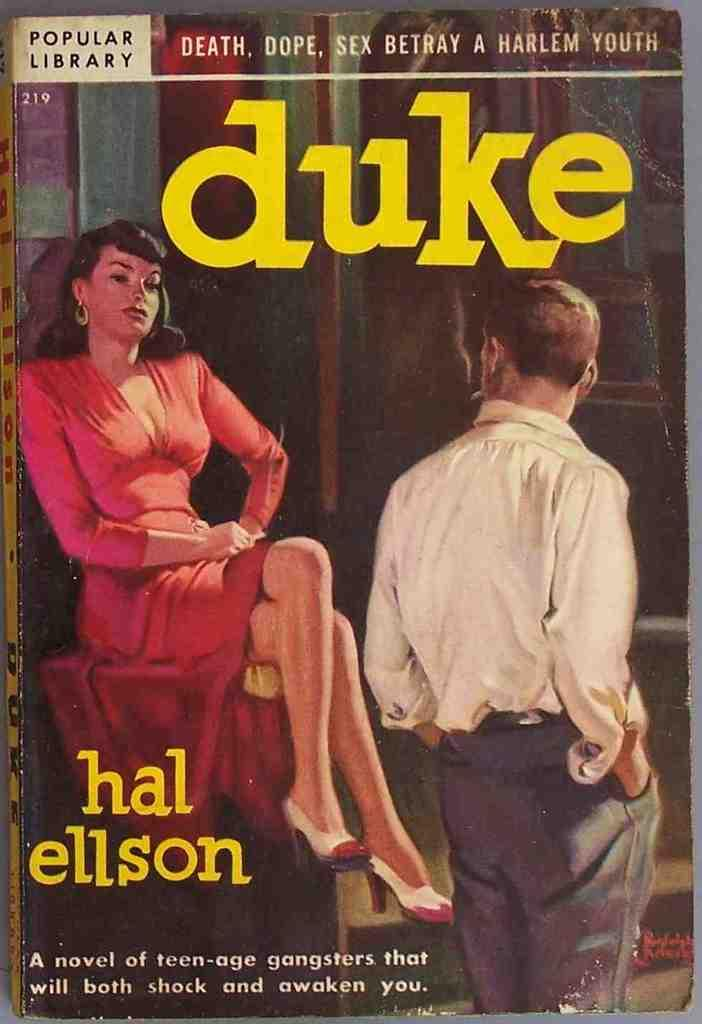<image>
Share a concise interpretation of the image provided. Duke, published by Popular LIbrary, is about teen-age gangsters. 